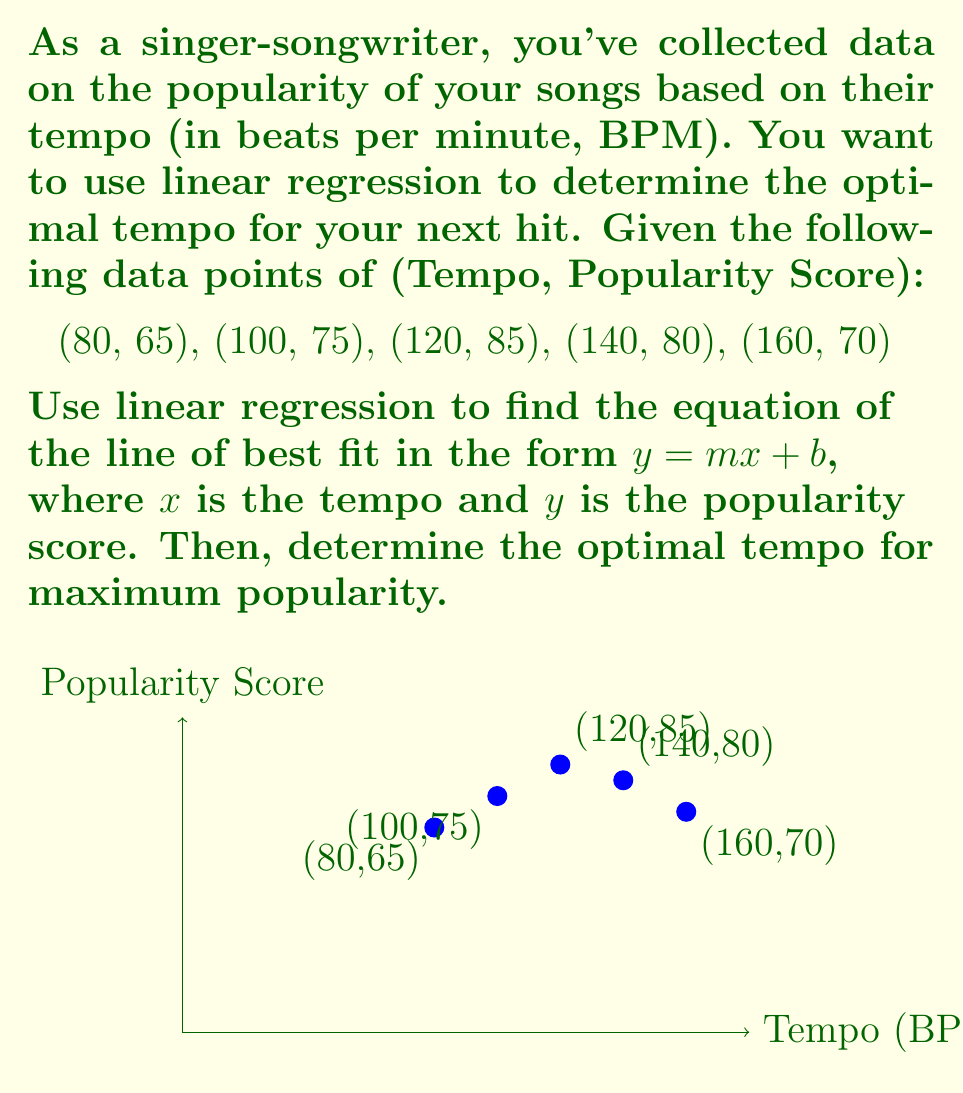Solve this math problem. Let's solve this step-by-step:

1) For linear regression, we need to calculate:
   $\sum x$, $\sum y$, $\sum xy$, $\sum x^2$, and $n$ (number of data points)

2) Calculate these values:
   $\sum x = 80 + 100 + 120 + 140 + 160 = 600$
   $\sum y = 65 + 75 + 85 + 80 + 70 = 375$
   $\sum xy = 80(65) + 100(75) + 120(85) + 140(80) + 160(70) = 46100$
   $\sum x^2 = 80^2 + 100^2 + 120^2 + 140^2 + 160^2 = 76000$
   $n = 5$

3) Use the linear regression formula to find $m$ (slope):
   $$m = \frac{n(\sum xy) - (\sum x)(\sum y)}{n(\sum x^2) - (\sum x)^2}$$
   $$m = \frac{5(46100) - (600)(375)}{5(76000) - (600)^2} = \frac{5500}{20000} = 0.275$$

4) Calculate $\bar{x}$ and $\bar{y}$ (means):
   $\bar{x} = \frac{\sum x}{n} = \frac{600}{5} = 120$
   $\bar{y} = \frac{\sum y}{n} = \frac{375}{5} = 75$

5) Use the point-slope form to find $b$ (y-intercept):
   $y - \bar{y} = m(x - \bar{x})$
   $75 = 0.275(120) + b$
   $b = 75 - 33 = 42$

6) The line of best fit is: $y = 0.275x + 42$

7) To find the optimal tempo, we need to find the maximum of this function. Since it's a linear function, the maximum will occur at one of the endpoints of our data range (80 BPM or 160 BPM).

8) Calculate $y$ for both endpoints:
   At 80 BPM: $y = 0.275(80) + 42 = 64$
   At 160 BPM: $y = 0.275(160) + 42 = 86$

9) The maximum occurs at 160 BPM, but our data shows a decline after 120 BPM. This suggests our linear model may not be the best fit for the entire range.

10) Given the data points, the optimal tempo appears to be around 120 BPM, which aligns with the peak in our original data.
Answer: 120 BPM 